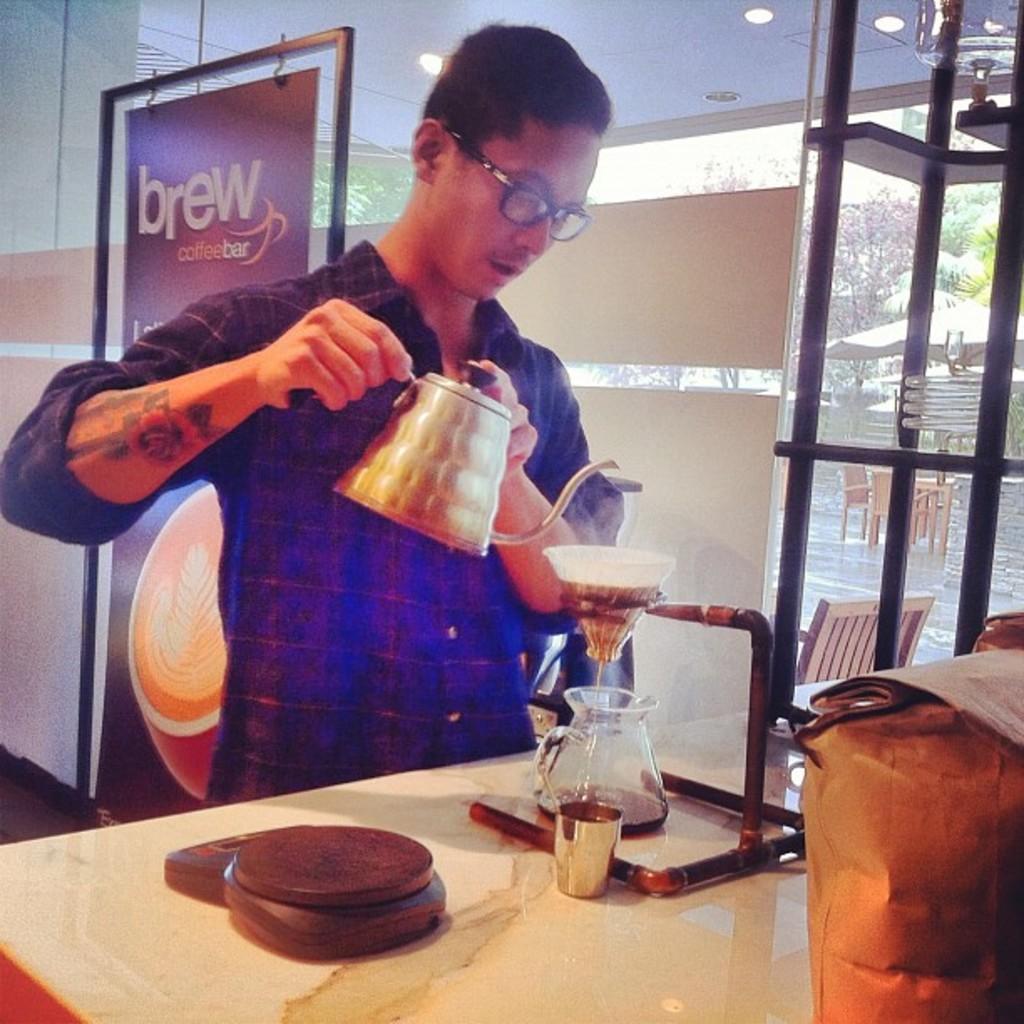Describe this image in one or two sentences. In this picture we can see a man who is standing on the floor. He is holding a jar with his hands. And this is the glass and these are the lights. Here we can see a frame. 